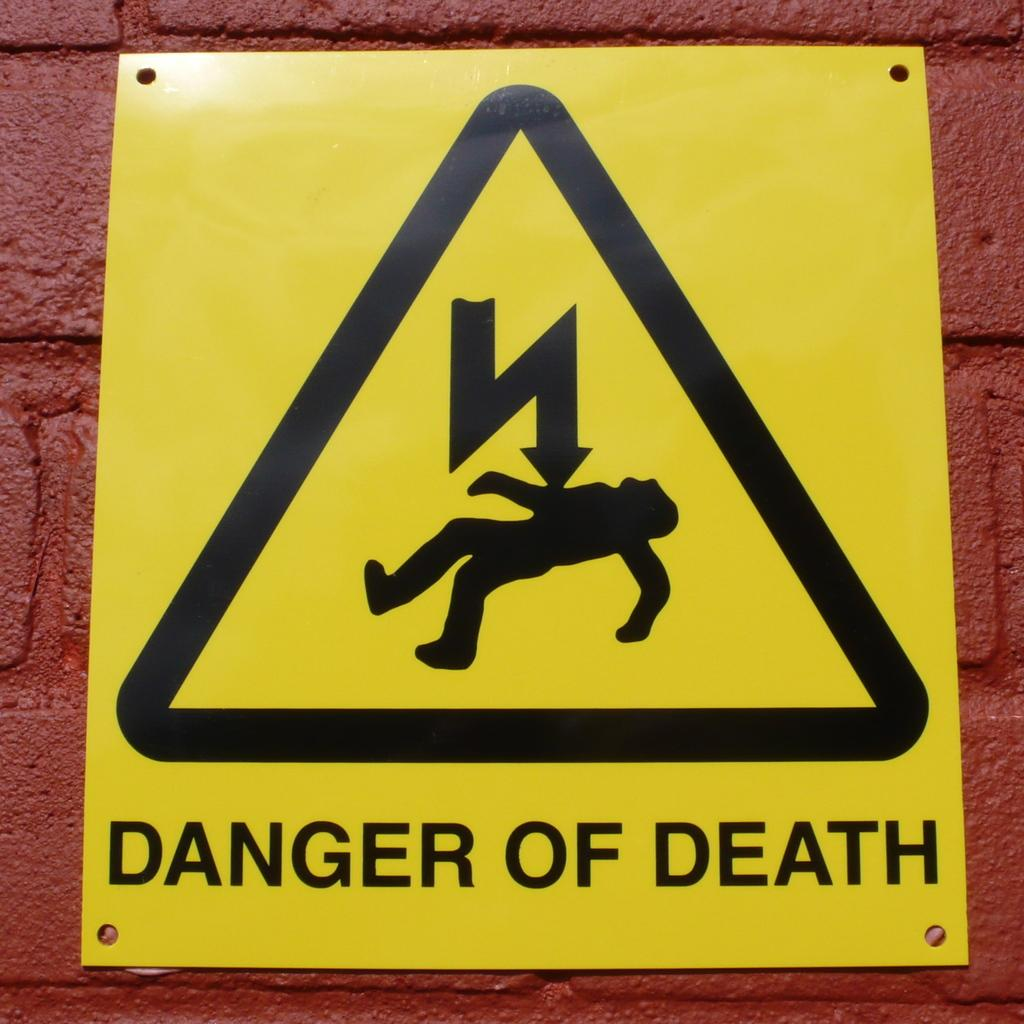What is the main object in the center of the image? The sign board is in the center of the image. Where is the sign board located? The sign board is on a wall. What can be inferred about the size or prominence of the sign board in the image? The sign board is in the center of the image, which suggests it is a significant or noticeable object. What type of tin plant is growing near the sign board in the image? There is no tin plant present in the image; the only object mentioned is the sign board. 